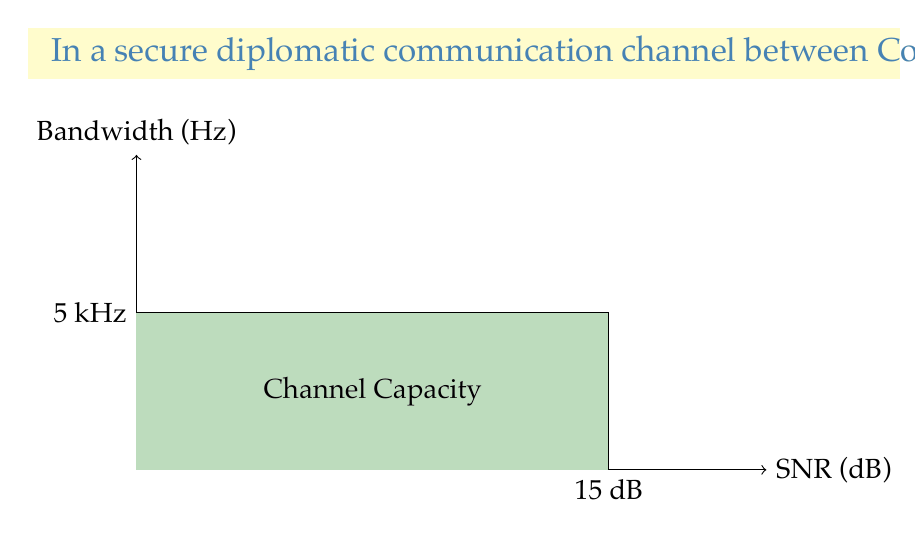Give your solution to this math problem. To solve this problem, we'll use the Shannon-Hartley theorem, which gives the channel capacity in bits per second. The formula is:

$$C = B \log_2(1 + SNR)$$

Where:
$C$ is the channel capacity in bits per second
$B$ is the bandwidth in Hertz
$SNR$ is the signal-to-noise ratio (linear, not dB)

Step 1: Convert the given bandwidth to Hertz
$B = 5 \text{ kHz} = 5000 \text{ Hz}$

Step 2: Convert the SNR from dB to linear scale
$SNR_{dB} = 15$
$SNR_{linear} = 10^{(SNR_{dB}/10)} = 10^{(15/10)} = 10^{1.5} \approx 31.6228$

Step 3: Apply the Shannon-Hartley theorem
$$\begin{align}
C &= B \log_2(1 + SNR) \\
&= 5000 \log_2(1 + 31.6228) \\
&= 5000 \log_2(32.6228) \\
&\approx 5000 \times 5.0279 \\
&\approx 25139.5 \text{ bits per second}
\end{align}$$

Step 4: Round to the nearest whole number
$C \approx 25140 \text{ bits per second}$

This channel capacity represents the theoretical maximum rate at which information can be transmitted over the diplomatic channel without error, given the specified bandwidth and signal-to-noise ratio.
Answer: 25140 bits per second 